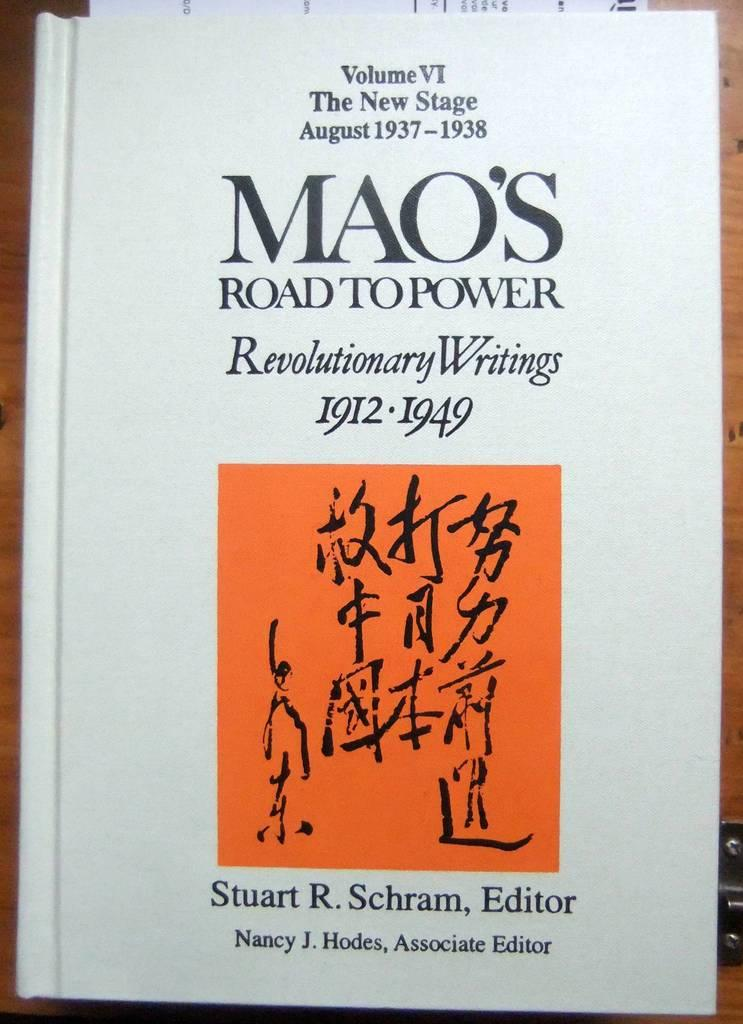<image>
Share a concise interpretation of the image provided. Mao's road to power book has an orange square with many letters on it 